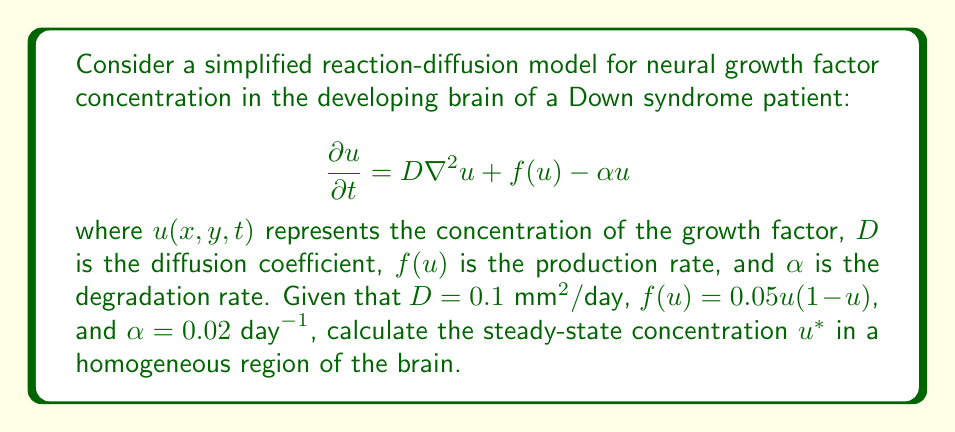Solve this math problem. To solve this problem, we need to follow these steps:

1) At steady-state, the concentration doesn't change with time, so $\frac{\partial u}{\partial t} = 0$.

2) In a homogeneous region, there's no spatial variation, so $\nabla^2u = 0$.

3) Substituting these into the original equation:

   $$0 = 0 + f(u^*) - \alpha u^*$$

4) Expand $f(u^*)$:

   $$0 = 0.05u^*(1-u^*) - 0.02u^*$$

5) Simplify:

   $$0 = 0.05u^* - 0.05(u^*)^2 - 0.02u^*$$
   $$0 = 0.03u^* - 0.05(u^*)^2$$

6) Factor out $u^*$:

   $$u^*(0.03 - 0.05u^*) = 0$$

7) Solve this equation. We have two possibilities:
   
   $u^* = 0$ or $0.03 - 0.05u^* = 0$

8) Solving the second equation:

   $$0.05u^* = 0.03$$
   $$u^* = 0.6$$

9) Therefore, we have two steady-state solutions: $u^* = 0$ and $u^* = 0.6$.

10) The zero solution represents the trivial case where no growth factor is present. The non-zero solution ($u^* = 0.6$) represents a biologically relevant steady-state concentration.
Answer: The biologically relevant steady-state concentration is $u^* = 0.6$. 